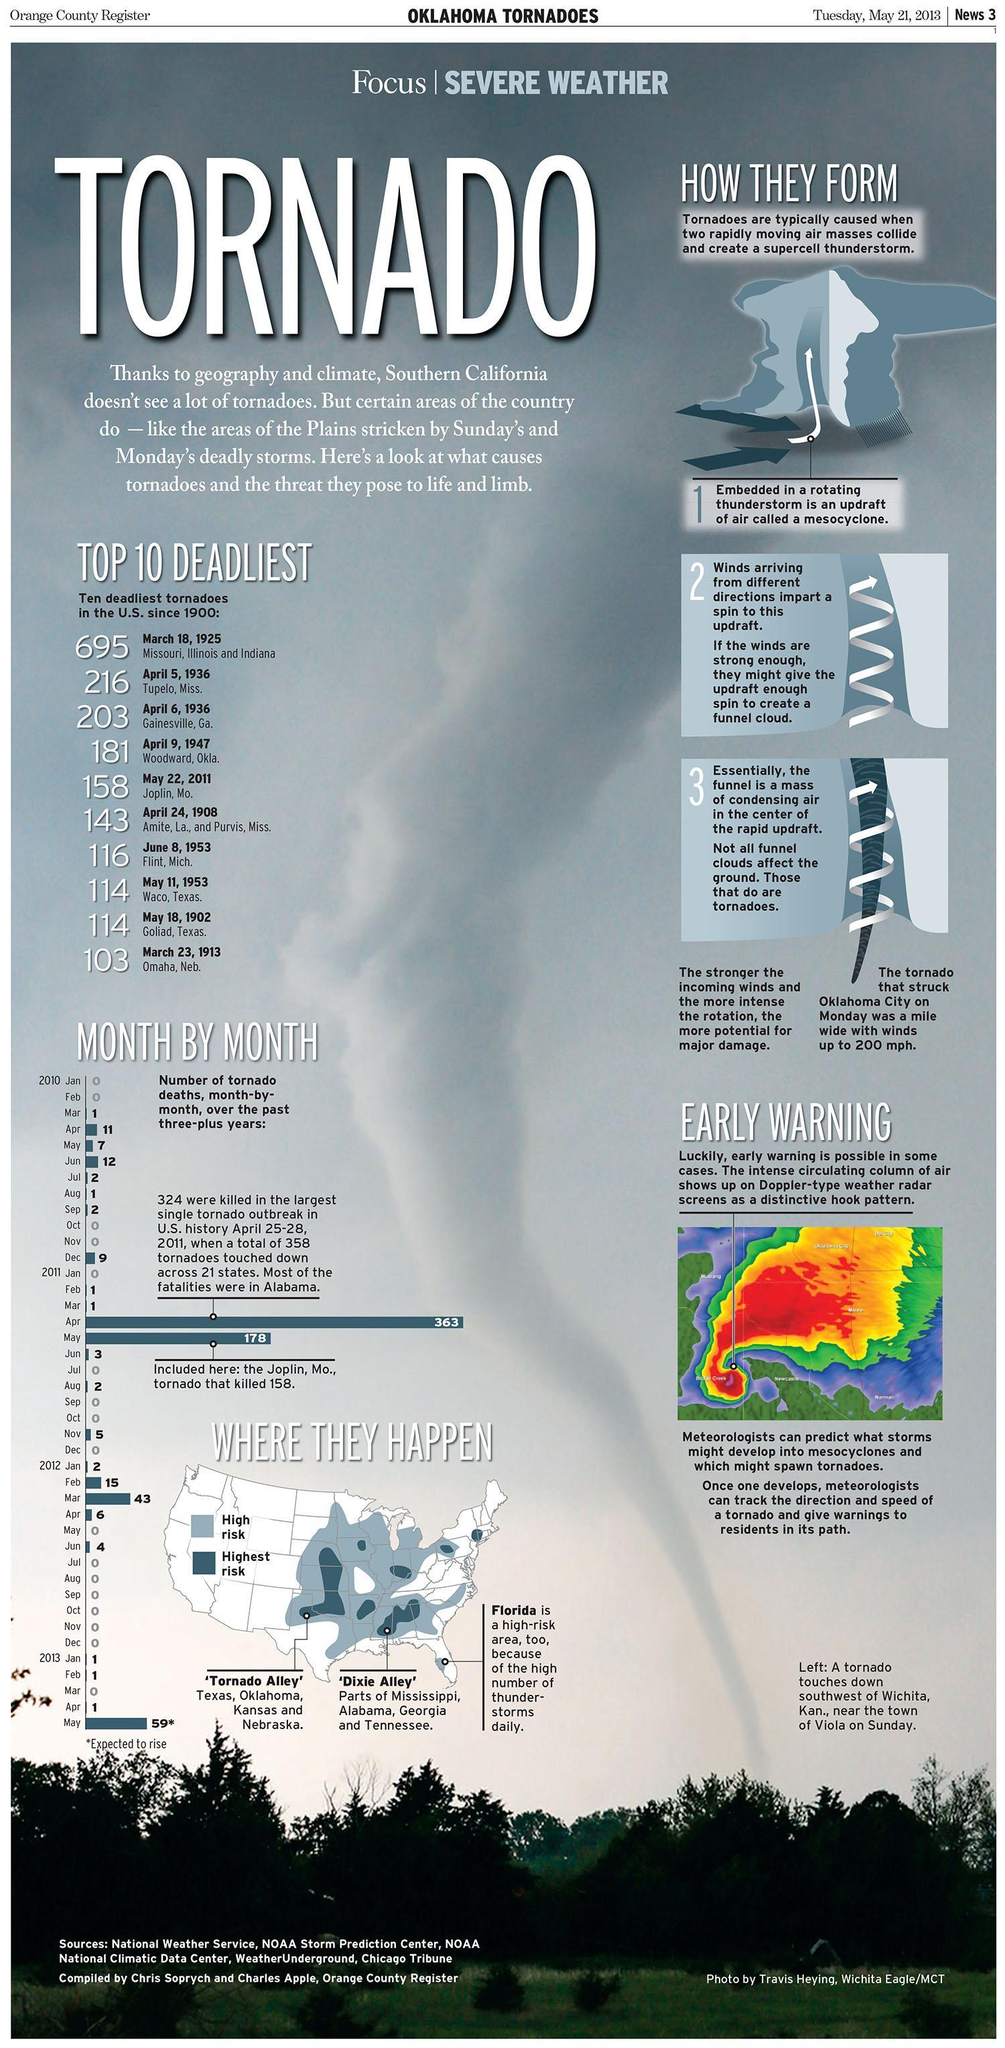What is the number of tornado deaths in the U.S. in June, 2010?
Answer the question with a short phrase. 12 What is the number of tornado deaths in the U.S. in July, 2011? 0 Which month in 2012 reported the highest number of tornado deaths in the U.S.? Mar How many people were killed by the tornado that occurred on April 5, 1936 in Tupelo? 216 Which month in 2010 reported the highest number of tornado deaths in the U.S.? Jun Which states in the U.S. were hit by the deadliest tornadoes on March 18, 1925? Missouri, Illinois and Indiana 